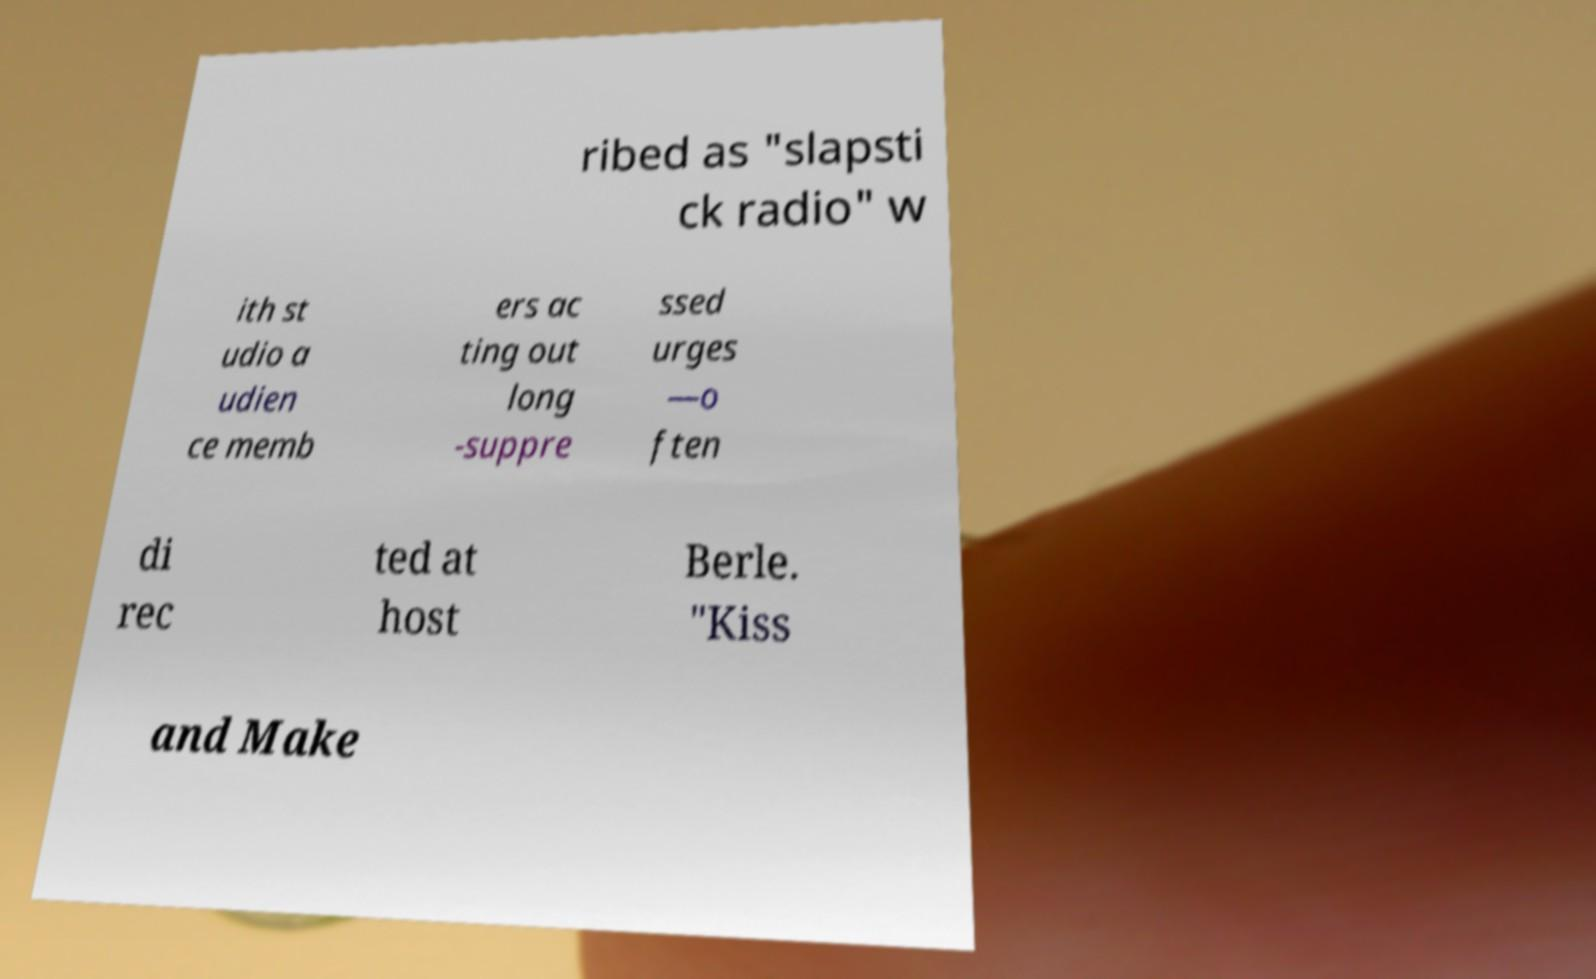Please identify and transcribe the text found in this image. ribed as "slapsti ck radio" w ith st udio a udien ce memb ers ac ting out long -suppre ssed urges —o ften di rec ted at host Berle. "Kiss and Make 